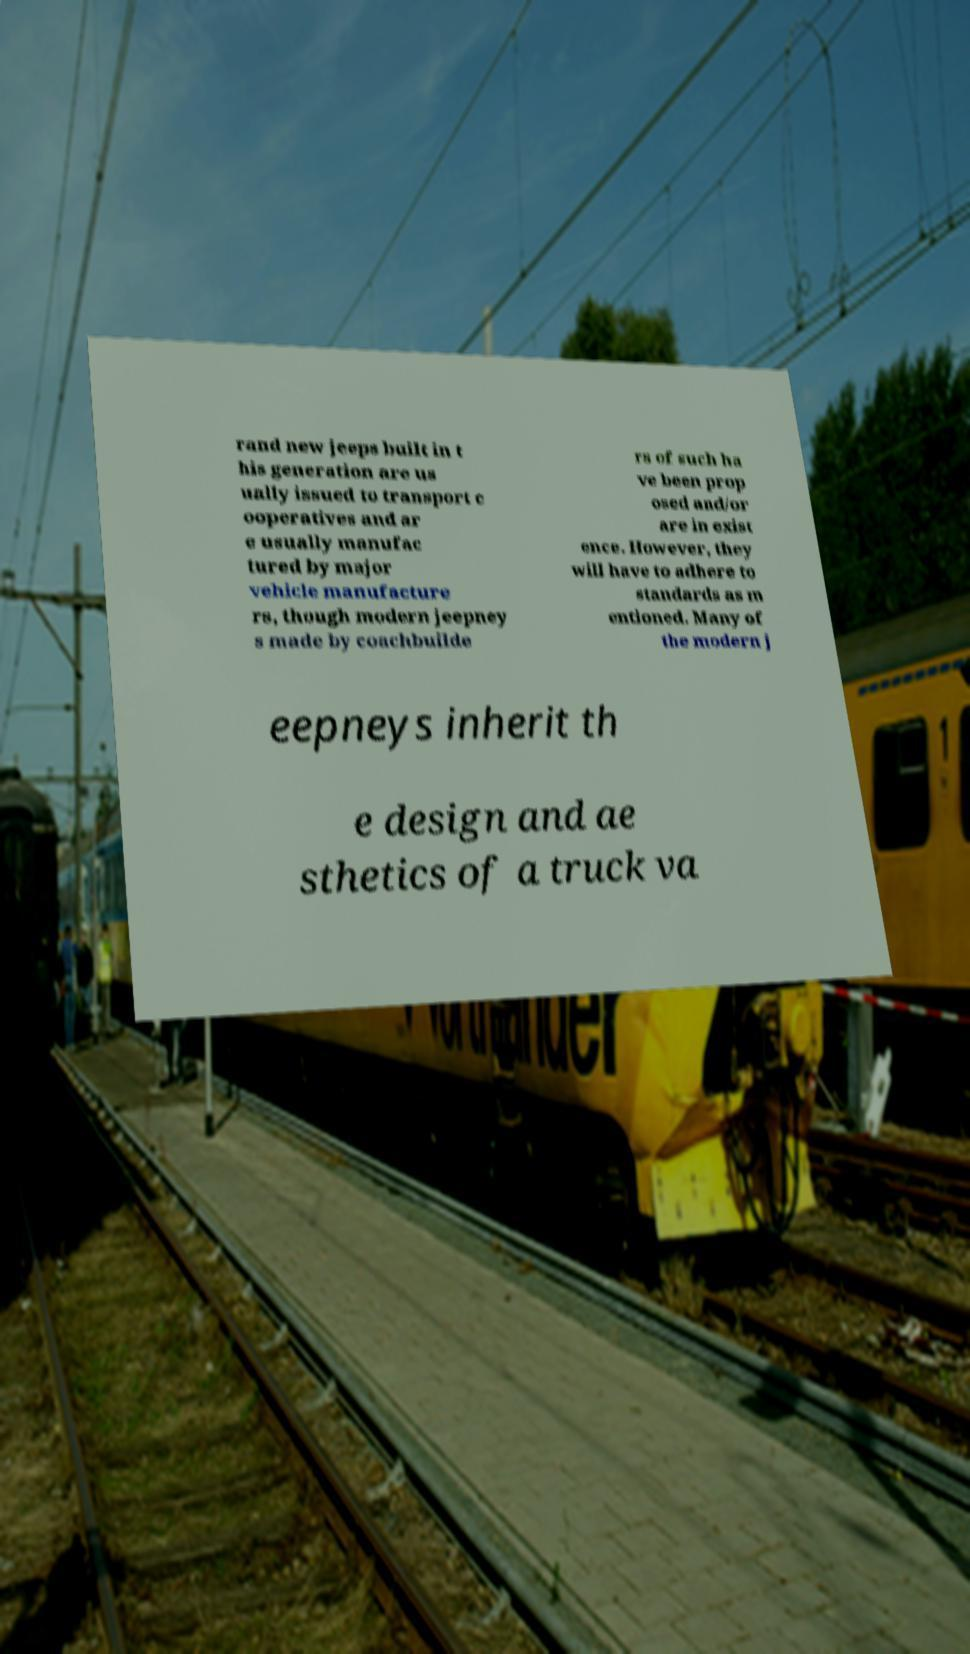Could you extract and type out the text from this image? rand new jeeps built in t his generation are us ually issued to transport c ooperatives and ar e usually manufac tured by major vehicle manufacture rs, though modern jeepney s made by coachbuilde rs of such ha ve been prop osed and/or are in exist ence. However, they will have to adhere to standards as m entioned. Many of the modern j eepneys inherit th e design and ae sthetics of a truck va 